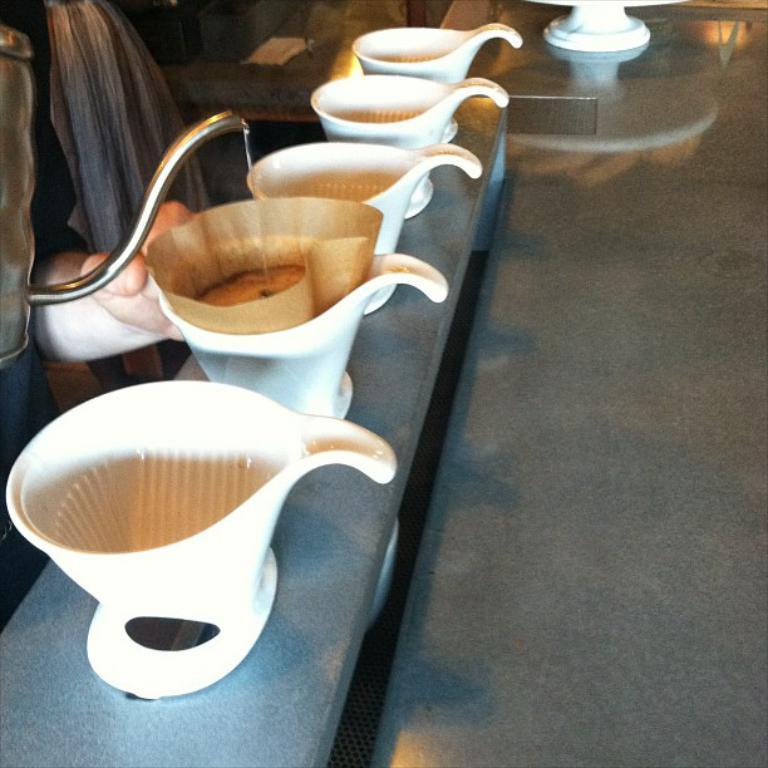Who is present in the image? There is a person in the image. What is the person holding in the image? The person is holding a kettle. What is the person doing with the kettle? The person is pouring a beverage into cups. How are the cups arranged in the image? The cups are placed on a tray in a row. What type of range can be seen in the image? There is no range present in the image. How many times does the person smash the cups in the image? The person does not smash any cups in the image; they are pouring a beverage into them. 